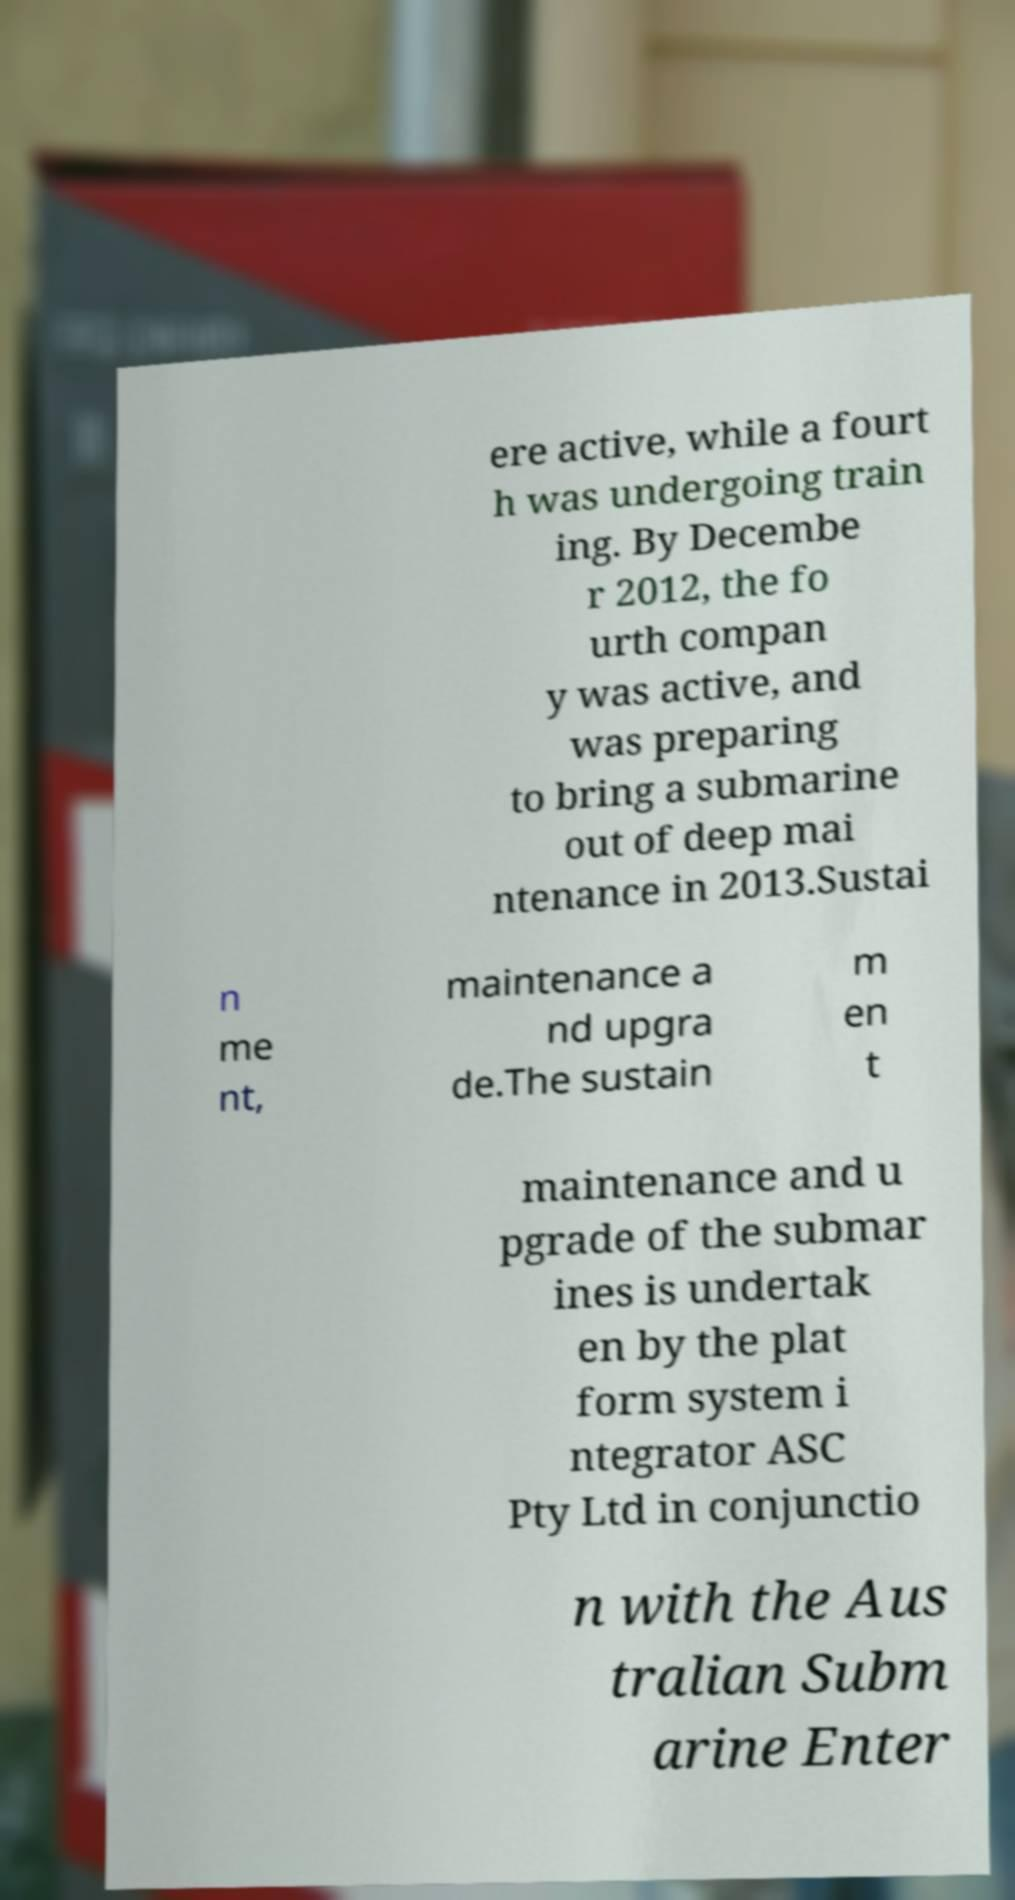Can you accurately transcribe the text from the provided image for me? ere active, while a fourt h was undergoing train ing. By Decembe r 2012, the fo urth compan y was active, and was preparing to bring a submarine out of deep mai ntenance in 2013.Sustai n me nt, maintenance a nd upgra de.The sustain m en t maintenance and u pgrade of the submar ines is undertak en by the plat form system i ntegrator ASC Pty Ltd in conjunctio n with the Aus tralian Subm arine Enter 